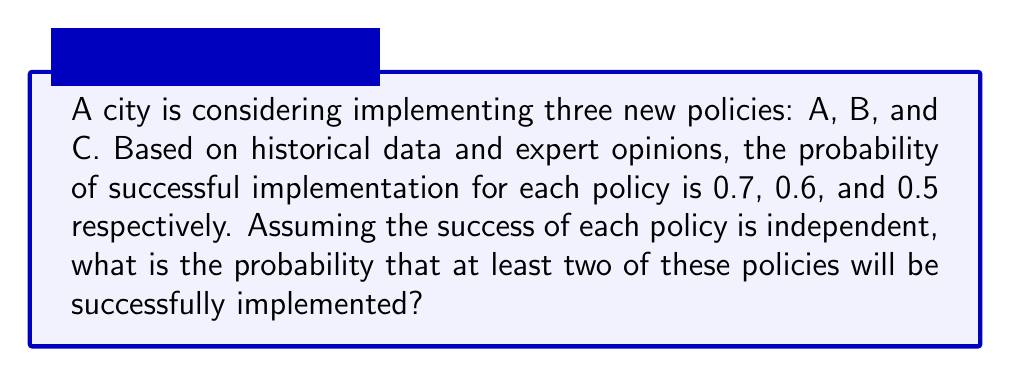Teach me how to tackle this problem. Let's approach this step-by-step:

1) First, we need to calculate the probability of at least two policies succeeding. This is equivalent to 1 minus the probability of zero or one policy succeeding.

2) Let's define our events:
   A: Policy A succeeds (P(A) = 0.7)
   B: Policy B succeeds (P(B) = 0.6)
   C: Policy C succeeds (P(C) = 0.5)

3) The probability of at least two succeeding = 1 - P(none succeed) - P(exactly one succeeds)

4) P(none succeed) = P(A' and B' and C')
   = (1 - 0.7) * (1 - 0.6) * (1 - 0.5)
   = 0.3 * 0.4 * 0.5 = 0.06

5) P(exactly one succeeds) = P(A and B' and C') + P(A' and B and C') + P(A' and B' and C)
   = 0.7 * 0.4 * 0.5 + 0.3 * 0.6 * 0.5 + 0.3 * 0.4 * 0.5
   = 0.14 + 0.09 + 0.06 = 0.29

6) Therefore, the probability of at least two succeeding:
   = 1 - P(none succeed) - P(exactly one succeeds)
   = 1 - 0.06 - 0.29
   = 0.65

7) As a conservative advisor, we might round this down to 0.64 or 64% for reporting purposes.
Answer: 0.65 (or 65%) 